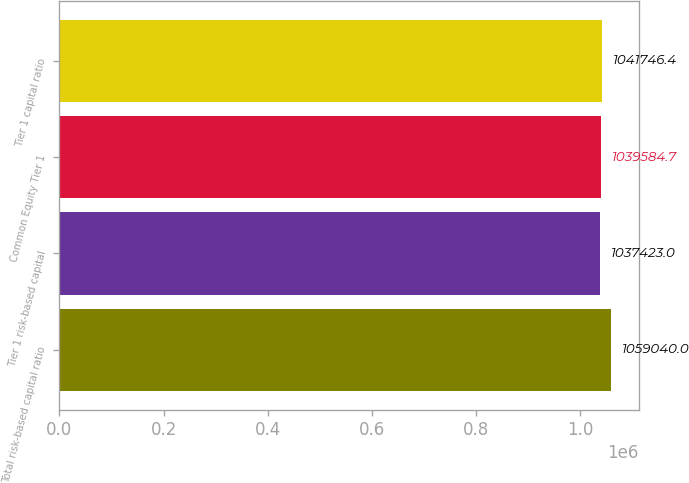Convert chart. <chart><loc_0><loc_0><loc_500><loc_500><bar_chart><fcel>Total risk-based capital ratio<fcel>Tier 1 risk-based capital<fcel>Common Equity Tier 1<fcel>Tier 1 capital ratio<nl><fcel>1.05904e+06<fcel>1.03742e+06<fcel>1.03958e+06<fcel>1.04175e+06<nl></chart> 